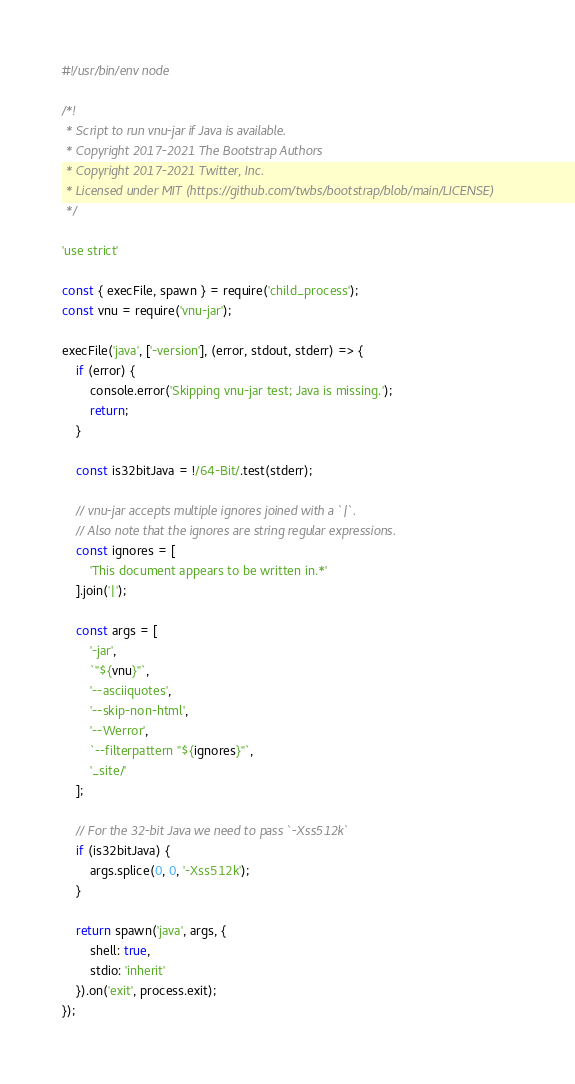Convert code to text. <code><loc_0><loc_0><loc_500><loc_500><_JavaScript_>#!/usr/bin/env node

/*!
 * Script to run vnu-jar if Java is available.
 * Copyright 2017-2021 The Bootstrap Authors
 * Copyright 2017-2021 Twitter, Inc.
 * Licensed under MIT (https://github.com/twbs/bootstrap/blob/main/LICENSE)
 */

'use strict'

const { execFile, spawn } = require('child_process');
const vnu = require('vnu-jar');

execFile('java', ['-version'], (error, stdout, stderr) => {
    if (error) {
        console.error('Skipping vnu-jar test; Java is missing.');
        return;
    }

    const is32bitJava = !/64-Bit/.test(stderr);

    // vnu-jar accepts multiple ignores joined with a `|`.
    // Also note that the ignores are string regular expressions.
    const ignores = [
        'This document appears to be written in.*'
    ].join('|');

    const args = [
        '-jar',
        `"${vnu}"`,
        '--asciiquotes',
        '--skip-non-html',
        '--Werror',
        `--filterpattern "${ignores}"`,
        '_site/'
    ];

    // For the 32-bit Java we need to pass `-Xss512k`
    if (is32bitJava) {
        args.splice(0, 0, '-Xss512k');
    }

    return spawn('java', args, {
        shell: true,
        stdio: 'inherit'
    }).on('exit', process.exit);
});
</code> 